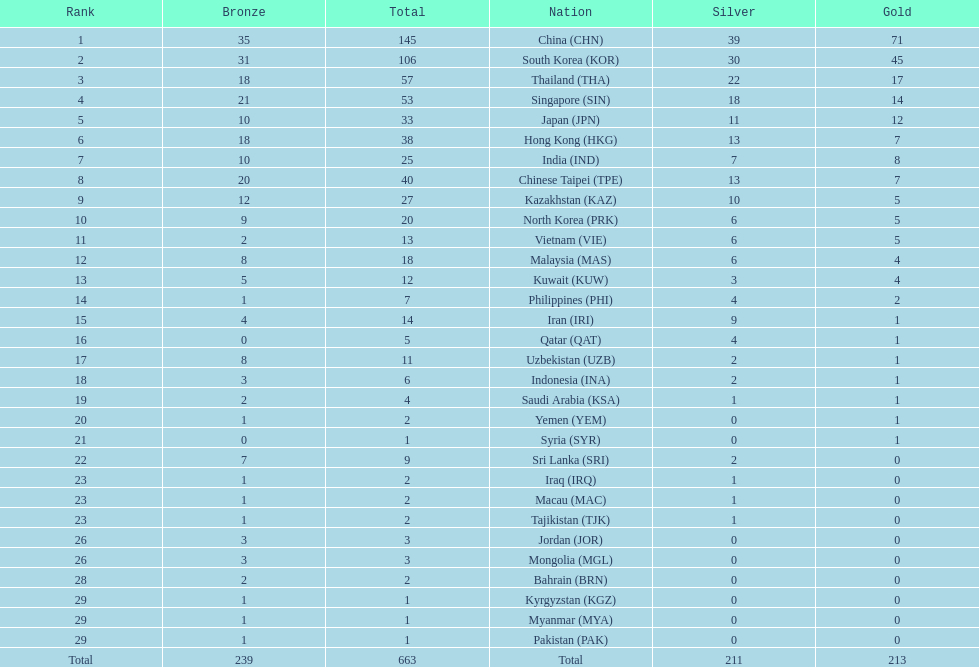How many countries have at least 10 gold medals in the asian youth games? 5. 